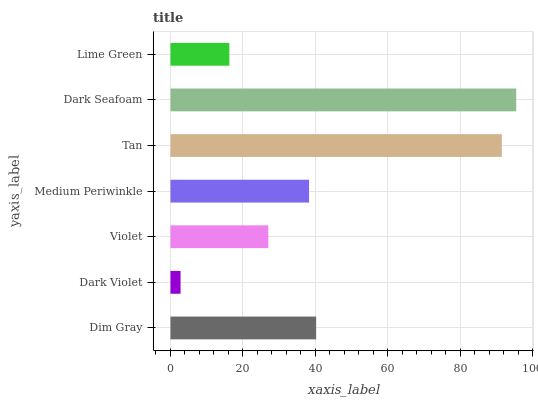Is Dark Violet the minimum?
Answer yes or no. Yes. Is Dark Seafoam the maximum?
Answer yes or no. Yes. Is Violet the minimum?
Answer yes or no. No. Is Violet the maximum?
Answer yes or no. No. Is Violet greater than Dark Violet?
Answer yes or no. Yes. Is Dark Violet less than Violet?
Answer yes or no. Yes. Is Dark Violet greater than Violet?
Answer yes or no. No. Is Violet less than Dark Violet?
Answer yes or no. No. Is Medium Periwinkle the high median?
Answer yes or no. Yes. Is Medium Periwinkle the low median?
Answer yes or no. Yes. Is Lime Green the high median?
Answer yes or no. No. Is Tan the low median?
Answer yes or no. No. 